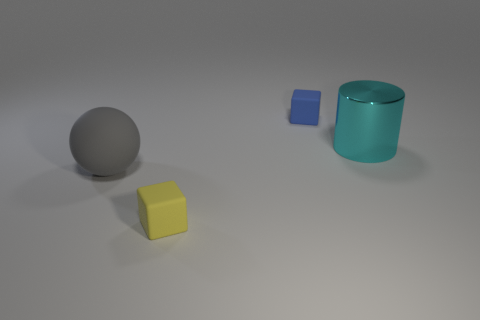Add 2 yellow objects. How many objects exist? 6 Subtract all blue blocks. How many blocks are left? 1 Add 3 rubber objects. How many rubber objects exist? 6 Subtract 1 gray spheres. How many objects are left? 3 Subtract all balls. How many objects are left? 3 Subtract 1 balls. How many balls are left? 0 Subtract all red cubes. Subtract all green cylinders. How many cubes are left? 2 Subtract all gray cylinders. How many yellow blocks are left? 1 Subtract all big cyan metallic cylinders. Subtract all cyan things. How many objects are left? 2 Add 1 small blue rubber blocks. How many small blue rubber blocks are left? 2 